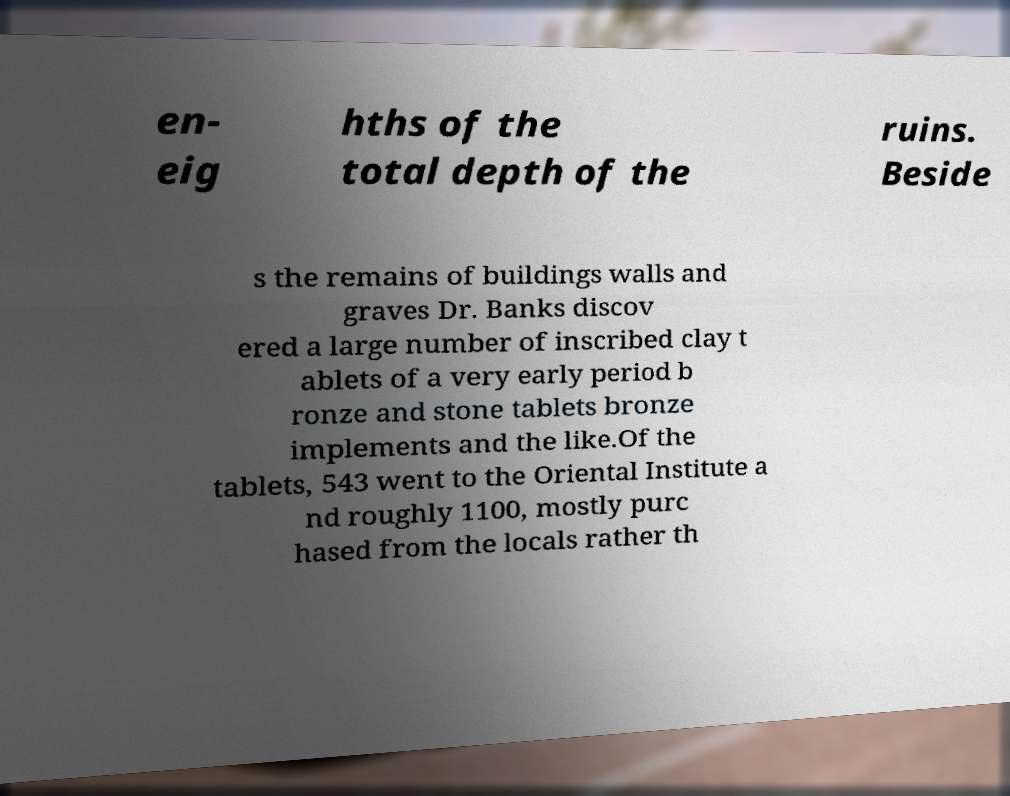For documentation purposes, I need the text within this image transcribed. Could you provide that? en- eig hths of the total depth of the ruins. Beside s the remains of buildings walls and graves Dr. Banks discov ered a large number of inscribed clay t ablets of a very early period b ronze and stone tablets bronze implements and the like.Of the tablets, 543 went to the Oriental Institute a nd roughly 1100, mostly purc hased from the locals rather th 